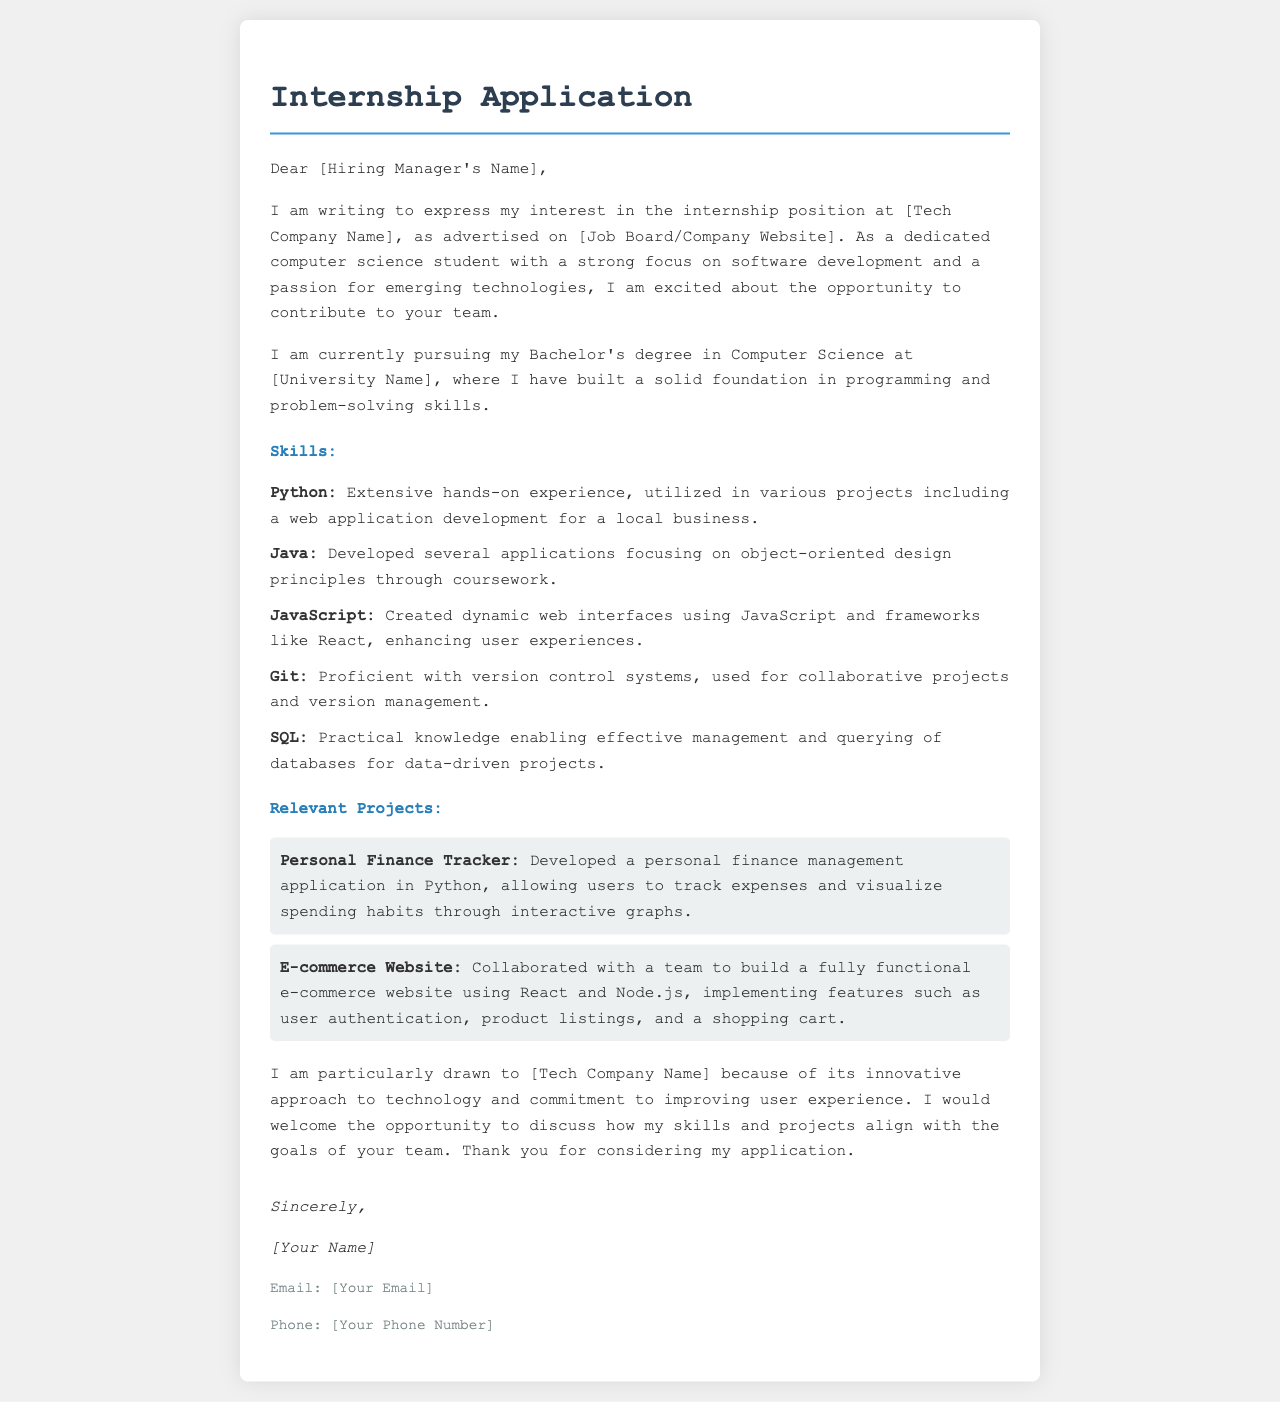What is the position being applied for? The document specifies that the applicant is writing for an internship position.
Answer: internship position Who is the letter addressed to? The document includes a placeholder for the hiring manager's name, indicating personalization intended for the recipient.
Answer: [Hiring Manager's Name] What skill is associated with extensive hands-on experience? The document lists specific skills and relates Python to extensive hands-on experience.
Answer: Python What was developed in Python according to the projects section? The projects section mentions a personal finance management application developed in Python.
Answer: personal finance management application Which programming language was used for creating dynamic web interfaces? The document states that JavaScript was used for creating dynamic web interfaces.
Answer: JavaScript How many relevant projects are described? The document provides details on two specific projects.
Answer: two What is the applicant's degree program? The document states that the applicant is pursuing a Bachelor's degree in Computer Science.
Answer: Bachelor's degree in Computer Science What technologies were used in the e-commerce website project? The document indicates that the e-commerce website was built using React and Node.js.
Answer: React and Node.js What does the applicant express admiration for regarding [Tech Company Name]? The document highlights the applicant's admiration for the company's innovative approach to technology.
Answer: innovative approach to technology 